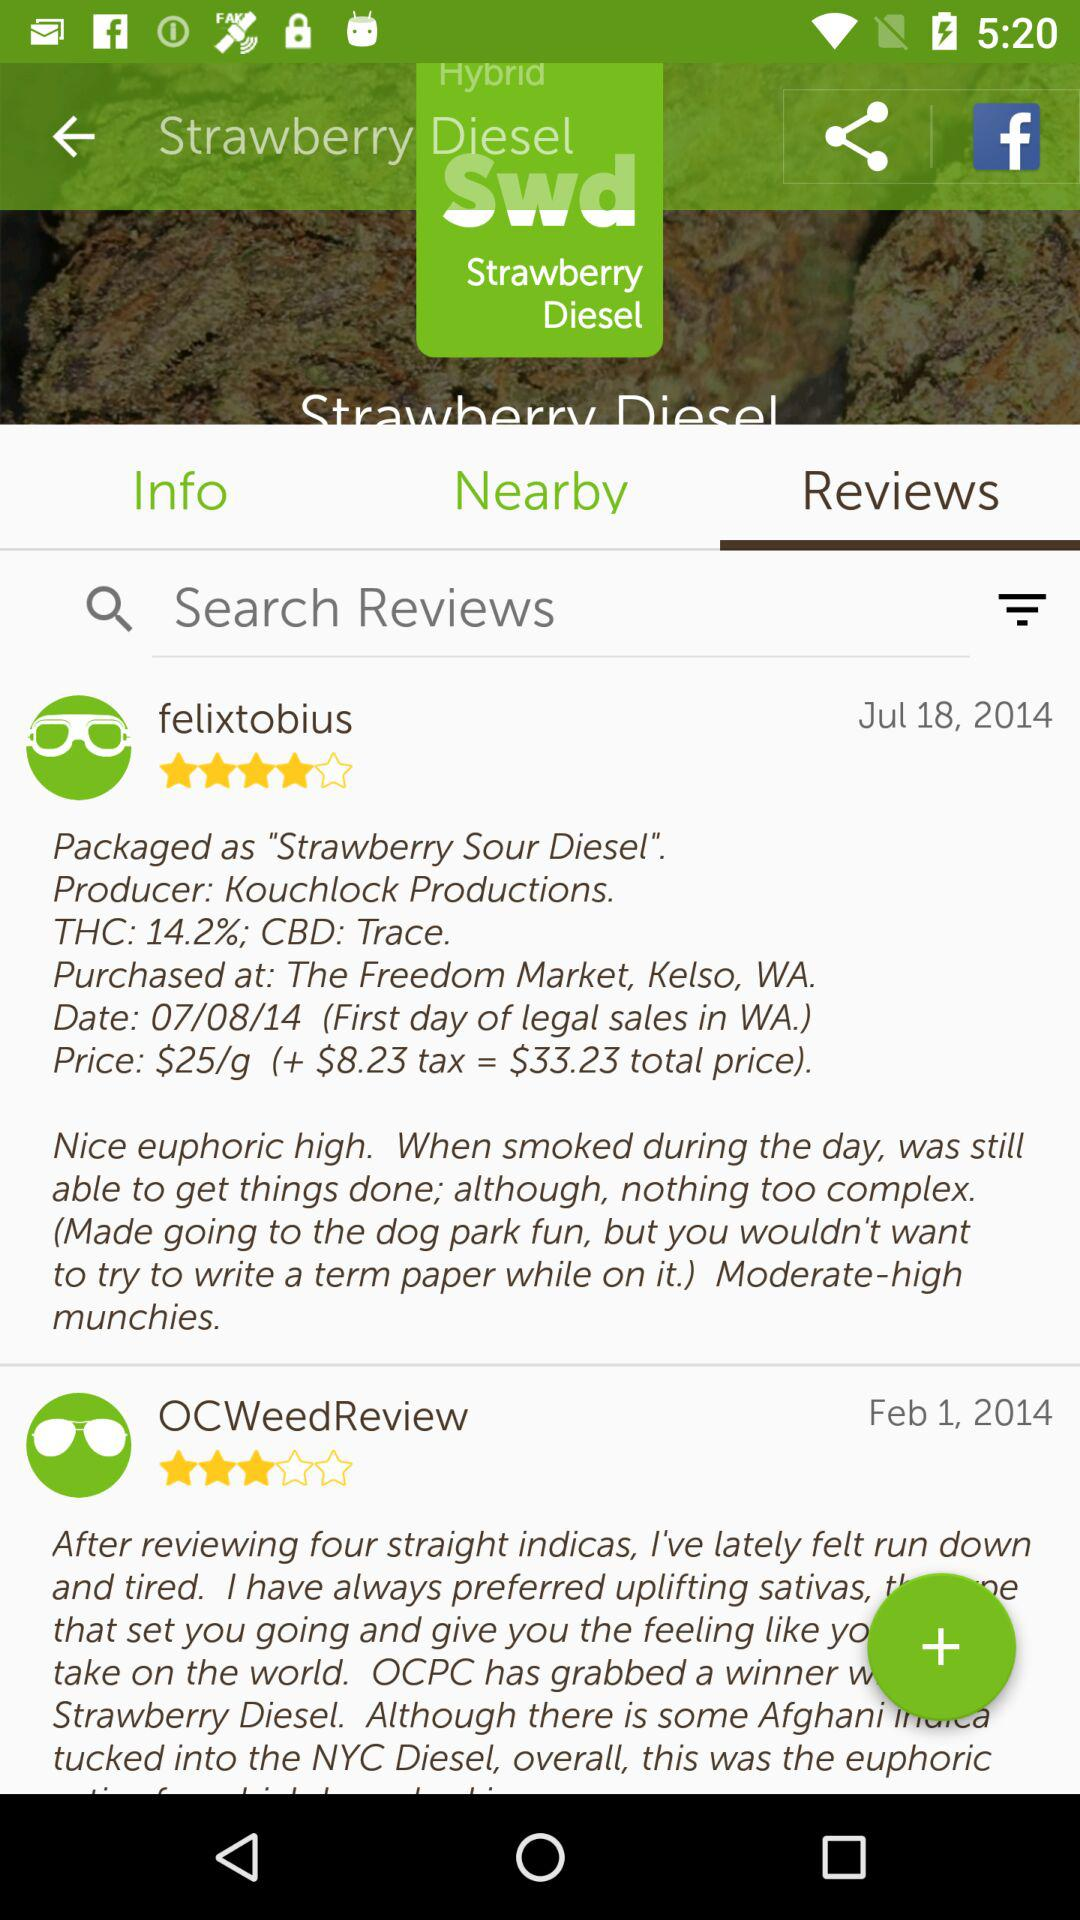How much was the total price of the strain?
Answer the question using a single word or phrase. $33.23 